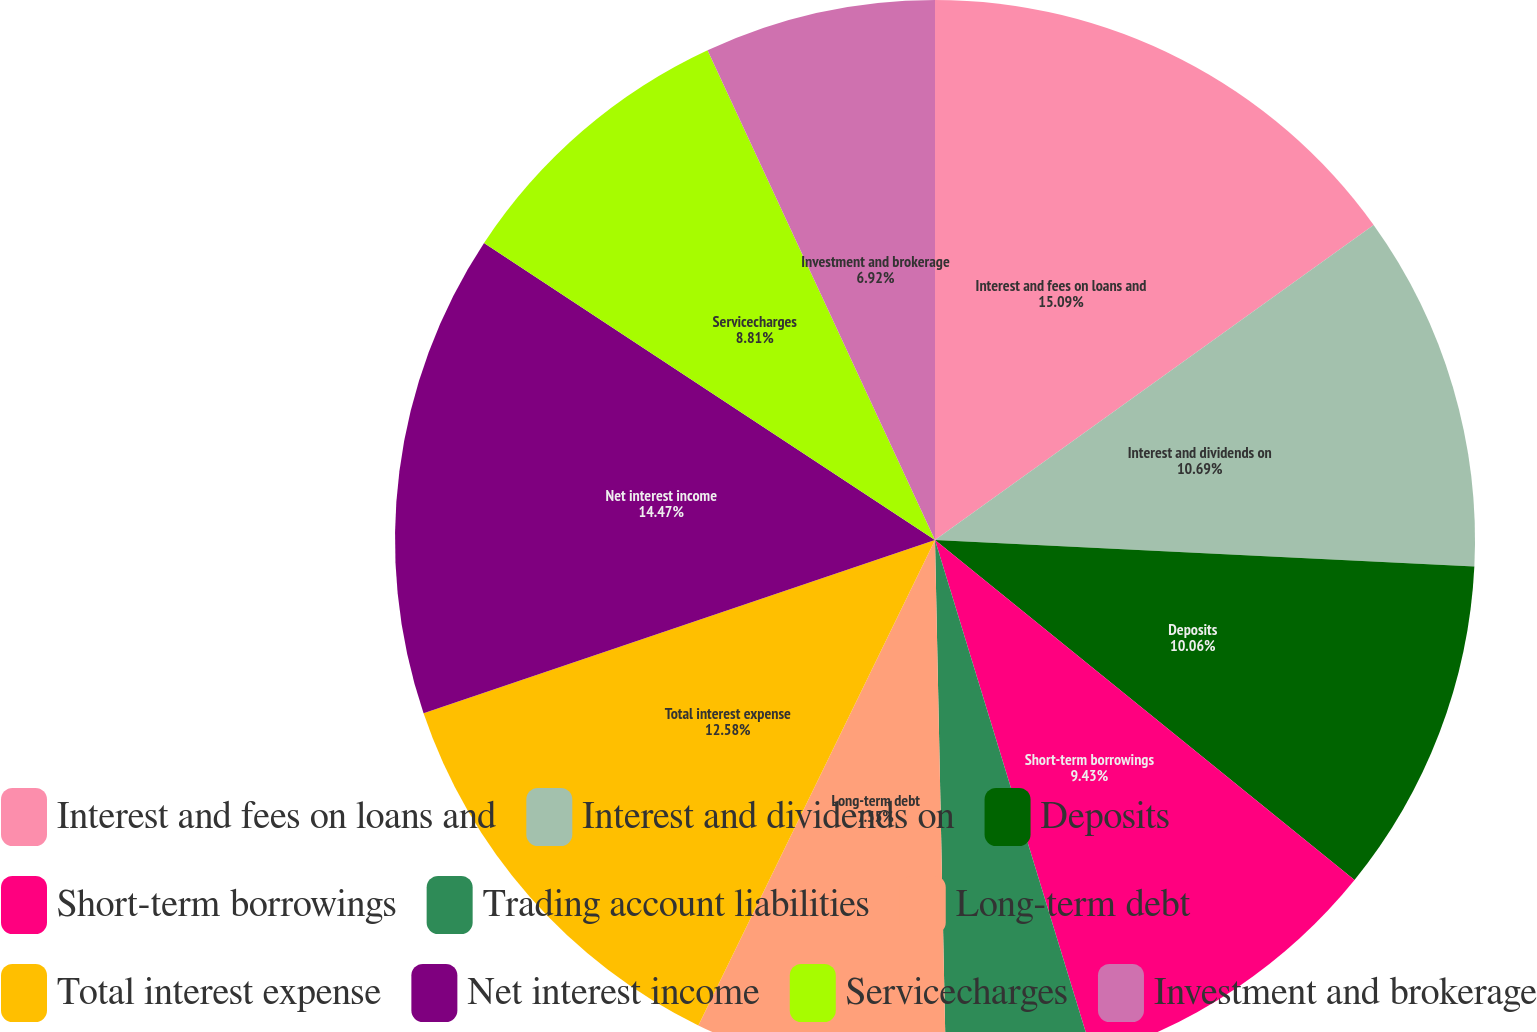<chart> <loc_0><loc_0><loc_500><loc_500><pie_chart><fcel>Interest and fees on loans and<fcel>Interest and dividends on<fcel>Deposits<fcel>Short-term borrowings<fcel>Trading account liabilities<fcel>Long-term debt<fcel>Total interest expense<fcel>Net interest income<fcel>Servicecharges<fcel>Investment and brokerage<nl><fcel>15.09%<fcel>10.69%<fcel>10.06%<fcel>9.43%<fcel>4.4%<fcel>7.55%<fcel>12.58%<fcel>14.47%<fcel>8.81%<fcel>6.92%<nl></chart> 